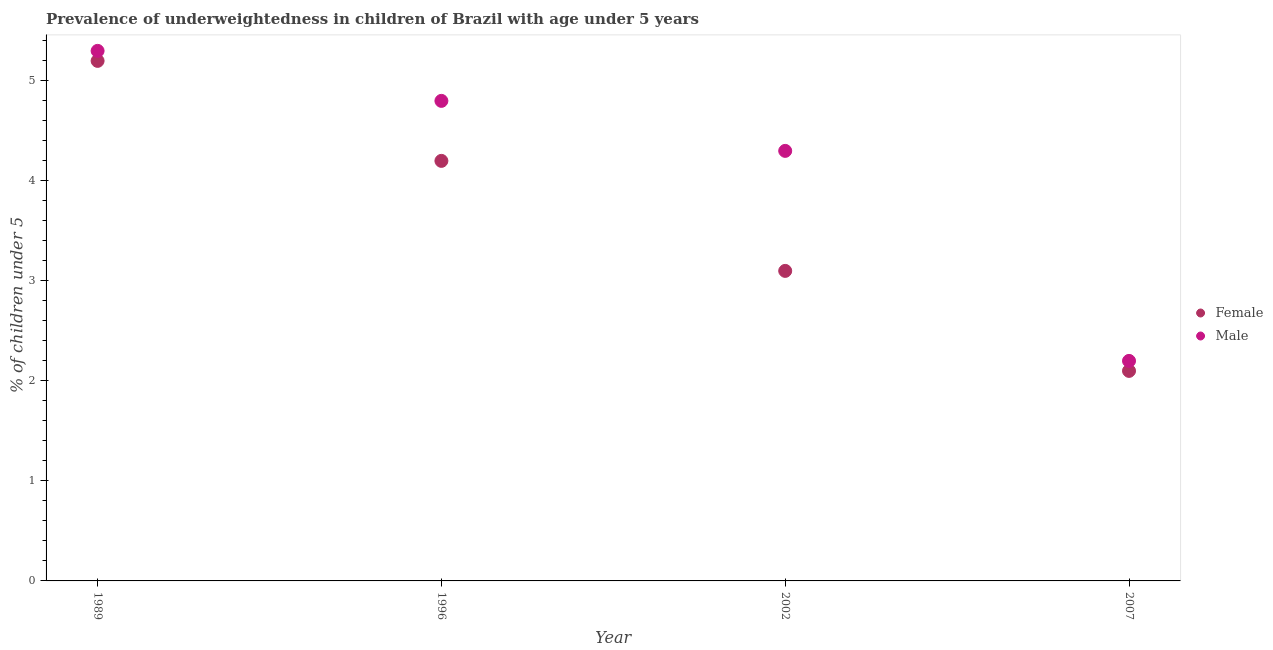What is the percentage of underweighted female children in 2007?
Make the answer very short. 2.1. Across all years, what is the maximum percentage of underweighted female children?
Offer a terse response. 5.2. Across all years, what is the minimum percentage of underweighted male children?
Your response must be concise. 2.2. What is the total percentage of underweighted female children in the graph?
Give a very brief answer. 14.6. What is the difference between the percentage of underweighted female children in 1989 and that in 1996?
Your answer should be compact. 1. What is the difference between the percentage of underweighted female children in 2007 and the percentage of underweighted male children in 1996?
Provide a short and direct response. -2.7. What is the average percentage of underweighted male children per year?
Ensure brevity in your answer.  4.15. In the year 2002, what is the difference between the percentage of underweighted male children and percentage of underweighted female children?
Offer a very short reply. 1.2. What is the ratio of the percentage of underweighted female children in 1989 to that in 2007?
Provide a succinct answer. 2.48. Is the percentage of underweighted female children in 1989 less than that in 2002?
Ensure brevity in your answer.  No. What is the difference between the highest and the lowest percentage of underweighted female children?
Your answer should be very brief. 3.1. In how many years, is the percentage of underweighted male children greater than the average percentage of underweighted male children taken over all years?
Your answer should be very brief. 3. Is the sum of the percentage of underweighted female children in 1989 and 2007 greater than the maximum percentage of underweighted male children across all years?
Give a very brief answer. Yes. Does the percentage of underweighted male children monotonically increase over the years?
Give a very brief answer. No. Are the values on the major ticks of Y-axis written in scientific E-notation?
Provide a succinct answer. No. Does the graph contain any zero values?
Offer a very short reply. No. Does the graph contain grids?
Your response must be concise. No. Where does the legend appear in the graph?
Offer a very short reply. Center right. How are the legend labels stacked?
Your answer should be very brief. Vertical. What is the title of the graph?
Offer a very short reply. Prevalence of underweightedness in children of Brazil with age under 5 years. What is the label or title of the X-axis?
Keep it short and to the point. Year. What is the label or title of the Y-axis?
Your answer should be compact.  % of children under 5. What is the  % of children under 5 of Female in 1989?
Make the answer very short. 5.2. What is the  % of children under 5 in Male in 1989?
Provide a succinct answer. 5.3. What is the  % of children under 5 in Female in 1996?
Keep it short and to the point. 4.2. What is the  % of children under 5 in Male in 1996?
Ensure brevity in your answer.  4.8. What is the  % of children under 5 in Female in 2002?
Offer a terse response. 3.1. What is the  % of children under 5 of Male in 2002?
Provide a short and direct response. 4.3. What is the  % of children under 5 in Female in 2007?
Provide a short and direct response. 2.1. What is the  % of children under 5 of Male in 2007?
Provide a succinct answer. 2.2. Across all years, what is the maximum  % of children under 5 of Female?
Give a very brief answer. 5.2. Across all years, what is the maximum  % of children under 5 of Male?
Provide a succinct answer. 5.3. Across all years, what is the minimum  % of children under 5 of Female?
Provide a succinct answer. 2.1. Across all years, what is the minimum  % of children under 5 of Male?
Make the answer very short. 2.2. What is the total  % of children under 5 of Male in the graph?
Make the answer very short. 16.6. What is the difference between the  % of children under 5 of Male in 1989 and that in 1996?
Provide a succinct answer. 0.5. What is the difference between the  % of children under 5 of Male in 1989 and that in 2002?
Keep it short and to the point. 1. What is the difference between the  % of children under 5 in Male in 1989 and that in 2007?
Your answer should be very brief. 3.1. What is the difference between the  % of children under 5 in Male in 1996 and that in 2002?
Make the answer very short. 0.5. What is the difference between the  % of children under 5 in Female in 1996 and that in 2007?
Provide a succinct answer. 2.1. What is the difference between the  % of children under 5 in Male in 1996 and that in 2007?
Your response must be concise. 2.6. What is the difference between the  % of children under 5 of Male in 2002 and that in 2007?
Offer a very short reply. 2.1. What is the difference between the  % of children under 5 of Female in 1989 and the  % of children under 5 of Male in 2002?
Offer a terse response. 0.9. What is the difference between the  % of children under 5 in Female in 1996 and the  % of children under 5 in Male in 2002?
Offer a terse response. -0.1. What is the difference between the  % of children under 5 in Female in 2002 and the  % of children under 5 in Male in 2007?
Your response must be concise. 0.9. What is the average  % of children under 5 of Female per year?
Make the answer very short. 3.65. What is the average  % of children under 5 of Male per year?
Keep it short and to the point. 4.15. In the year 1989, what is the difference between the  % of children under 5 in Female and  % of children under 5 in Male?
Offer a very short reply. -0.1. In the year 1996, what is the difference between the  % of children under 5 of Female and  % of children under 5 of Male?
Make the answer very short. -0.6. In the year 2002, what is the difference between the  % of children under 5 of Female and  % of children under 5 of Male?
Offer a terse response. -1.2. In the year 2007, what is the difference between the  % of children under 5 of Female and  % of children under 5 of Male?
Keep it short and to the point. -0.1. What is the ratio of the  % of children under 5 of Female in 1989 to that in 1996?
Your response must be concise. 1.24. What is the ratio of the  % of children under 5 of Male in 1989 to that in 1996?
Provide a short and direct response. 1.1. What is the ratio of the  % of children under 5 in Female in 1989 to that in 2002?
Offer a terse response. 1.68. What is the ratio of the  % of children under 5 in Male in 1989 to that in 2002?
Provide a short and direct response. 1.23. What is the ratio of the  % of children under 5 of Female in 1989 to that in 2007?
Provide a succinct answer. 2.48. What is the ratio of the  % of children under 5 of Male in 1989 to that in 2007?
Keep it short and to the point. 2.41. What is the ratio of the  % of children under 5 of Female in 1996 to that in 2002?
Your response must be concise. 1.35. What is the ratio of the  % of children under 5 in Male in 1996 to that in 2002?
Offer a terse response. 1.12. What is the ratio of the  % of children under 5 in Male in 1996 to that in 2007?
Give a very brief answer. 2.18. What is the ratio of the  % of children under 5 in Female in 2002 to that in 2007?
Provide a short and direct response. 1.48. What is the ratio of the  % of children under 5 in Male in 2002 to that in 2007?
Keep it short and to the point. 1.95. What is the difference between the highest and the second highest  % of children under 5 of Female?
Your answer should be compact. 1. What is the difference between the highest and the second highest  % of children under 5 of Male?
Offer a terse response. 0.5. What is the difference between the highest and the lowest  % of children under 5 in Female?
Provide a short and direct response. 3.1. 